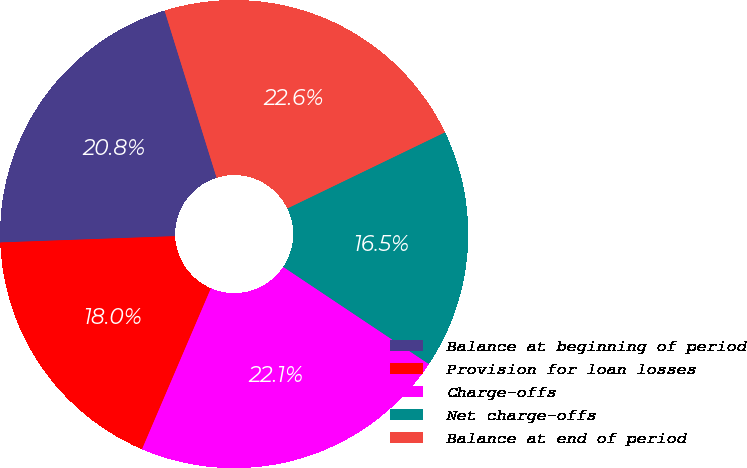<chart> <loc_0><loc_0><loc_500><loc_500><pie_chart><fcel>Balance at beginning of period<fcel>Provision for loan losses<fcel>Charge-offs<fcel>Net charge-offs<fcel>Balance at end of period<nl><fcel>20.77%<fcel>17.99%<fcel>22.07%<fcel>16.53%<fcel>22.64%<nl></chart> 